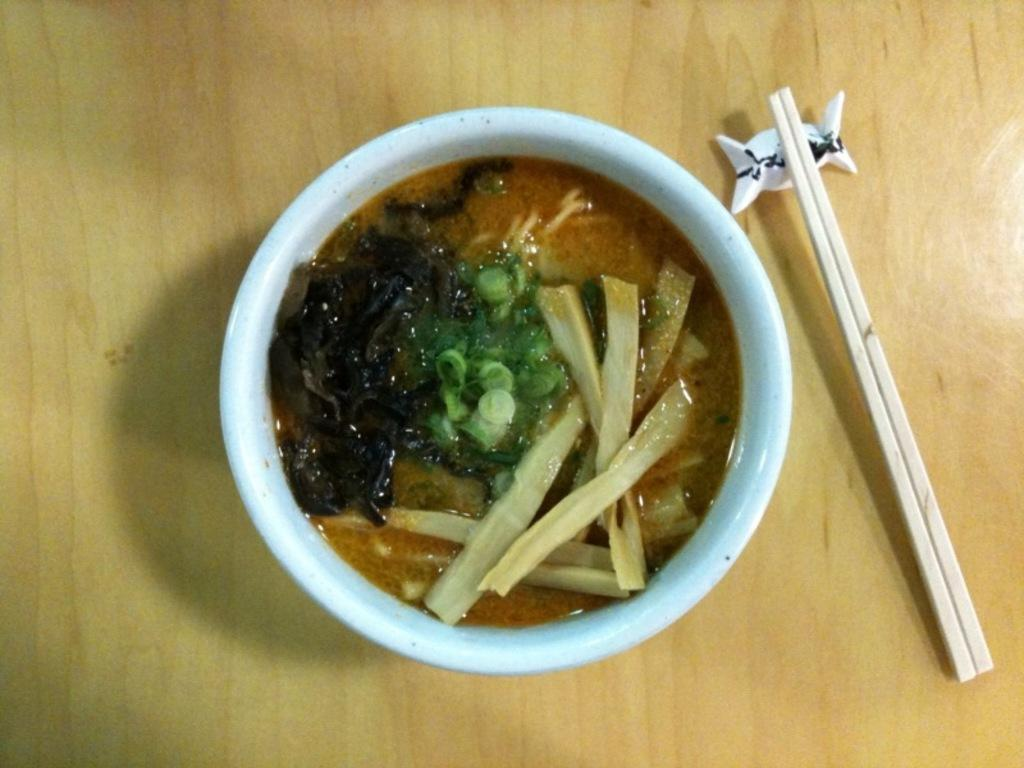What is in the bowl that is visible in the image? There is a bowl with a food item in the image. What utensils are present in the image? There are two sticks in the image. What symbol can be seen in the image? There is a chocolate symbol in the image. On what surface are the objects placed? The objects are placed on a wooden table. What type of juice can be seen in the image? There is no juice present in the image; it features a bowl with a food item, two sticks, and a chocolate symbol on a wooden table. 